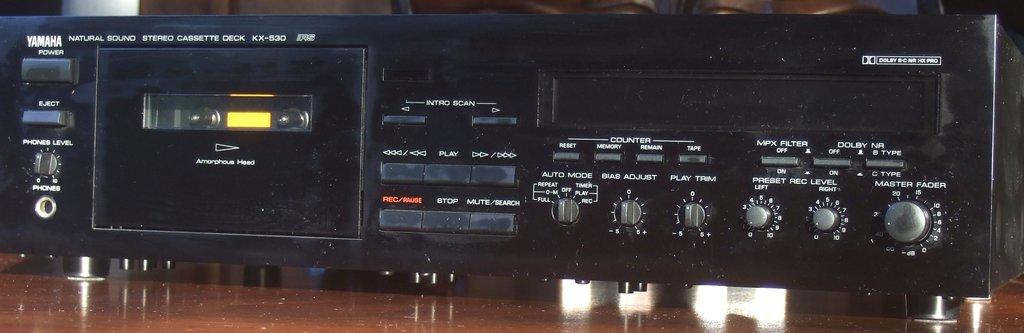Provide a one-sentence caption for the provided image. yamaha power player in black placed on the desk. 